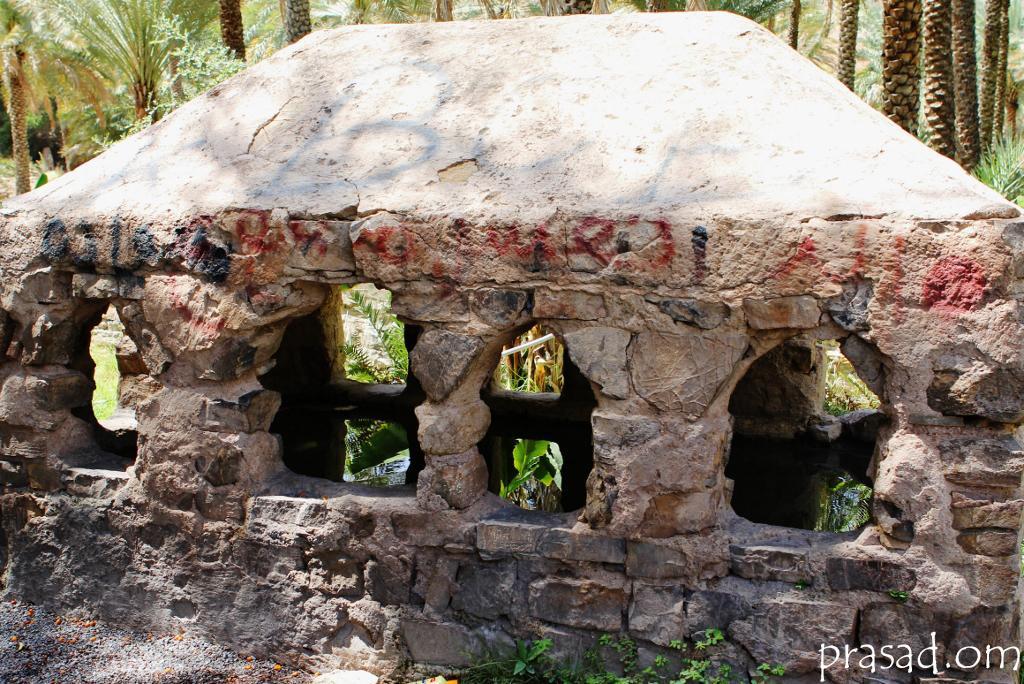In one or two sentences, can you explain what this image depicts? There is a stone room. Behind that there are trees. 